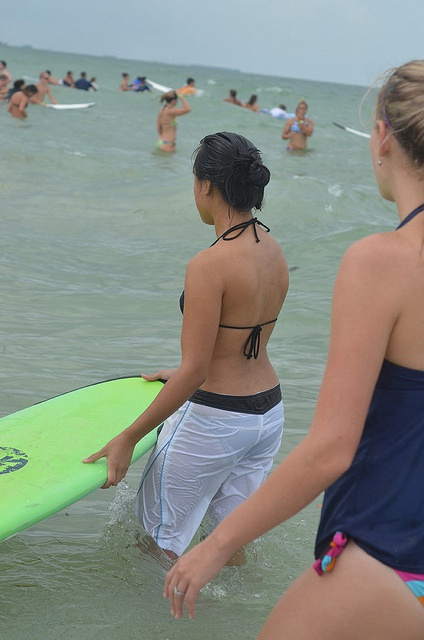Describe the objects in this image and their specific colors. I can see people in lightblue, gray, salmon, navy, and black tones, people in lightblue, gray, darkgray, and black tones, surfboard in lightblue, lightgreen, and green tones, people in lightblue, gray, and darkgray tones, and people in lightblue and gray tones in this image. 